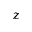<formula> <loc_0><loc_0><loc_500><loc_500>z</formula> 